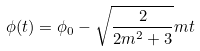<formula> <loc_0><loc_0><loc_500><loc_500>\phi ( t ) = \phi _ { 0 } - \sqrt { \frac { 2 } { 2 m ^ { 2 } + 3 } } m t</formula> 